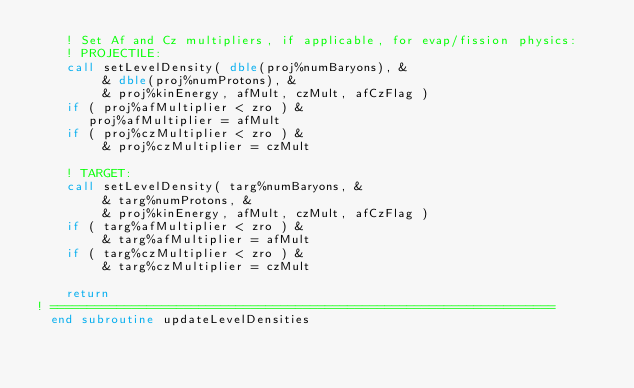<code> <loc_0><loc_0><loc_500><loc_500><_FORTRAN_>    ! Set Af and Cz multipliers, if applicable, for evap/fission physics:
    ! PROJECTILE:
    call setLevelDensity( dble(proj%numBaryons), &
         & dble(proj%numProtons), &
         & proj%kinEnergy, afMult, czMult, afCzFlag )
    if ( proj%afMultiplier < zro ) &
       proj%afMultiplier = afMult
    if ( proj%czMultiplier < zro ) &
         & proj%czMultiplier = czMult

    ! TARGET:
    call setLevelDensity( targ%numBaryons, &
         & targ%numProtons, &
         & proj%kinEnergy, afMult, czMult, afCzFlag )
    if ( targ%afMultiplier < zro ) &
         & targ%afMultiplier = afMult
    if ( targ%czMultiplier < zro ) &
         & targ%czMultiplier = czMult

    return
! ====================================================================
  end subroutine updateLevelDensities
</code> 